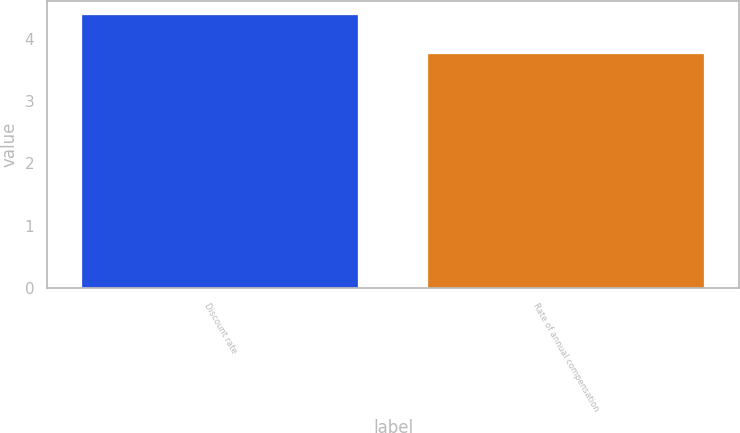<chart> <loc_0><loc_0><loc_500><loc_500><bar_chart><fcel>Discount rate<fcel>Rate of annual compensation<nl><fcel>4.38<fcel>3.75<nl></chart> 